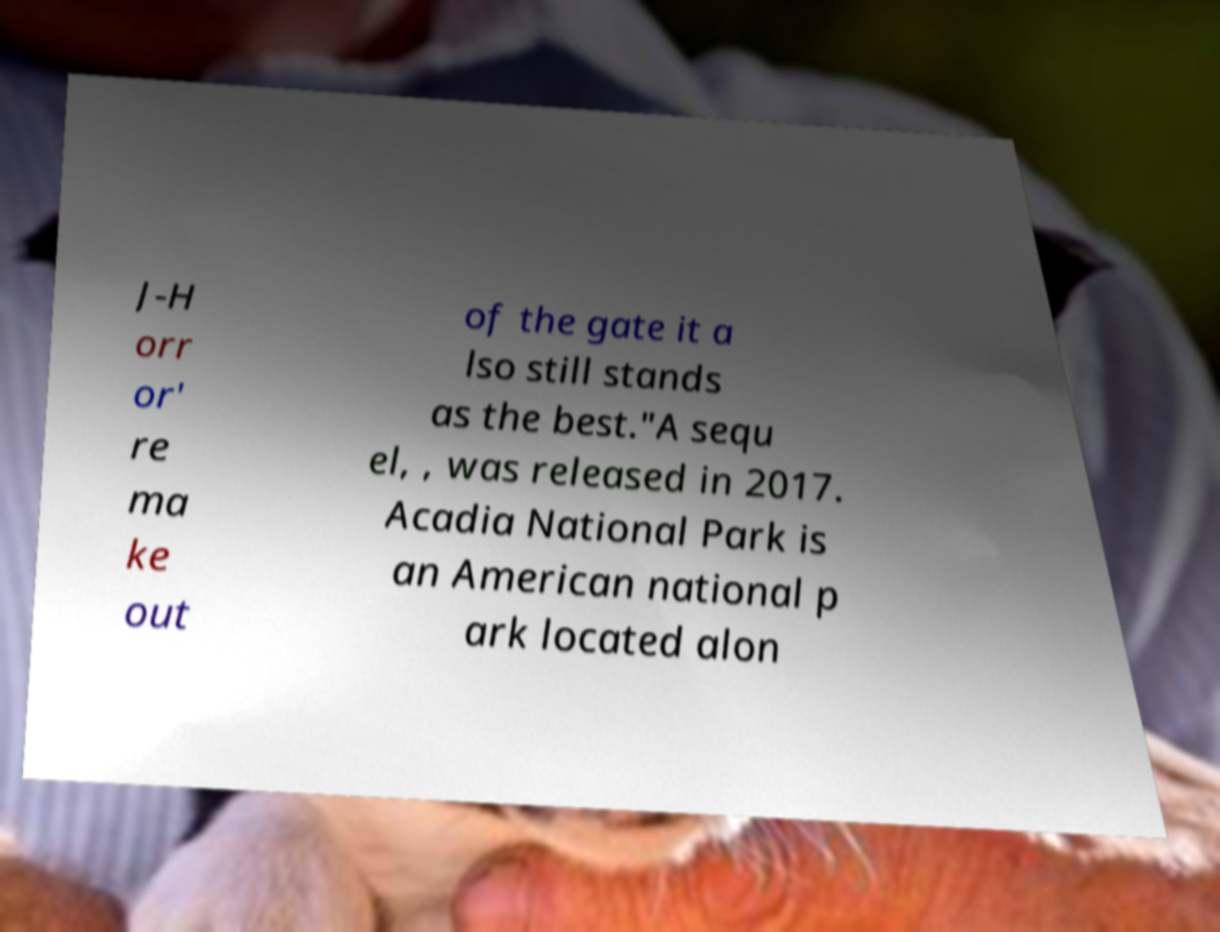Please read and relay the text visible in this image. What does it say? J-H orr or' re ma ke out of the gate it a lso still stands as the best."A sequ el, , was released in 2017. Acadia National Park is an American national p ark located alon 